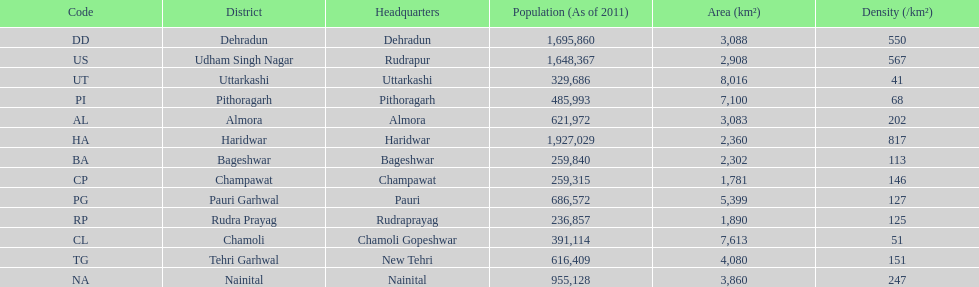Which headquarter has the same district name but has a density of 202? Almora. 